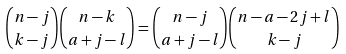<formula> <loc_0><loc_0><loc_500><loc_500>\binom { n - j } { k - j } \binom { n - k } { a + j - l } = \binom { n - j } { a + j - l } \binom { n - a - 2 j + l } { k - j }</formula> 